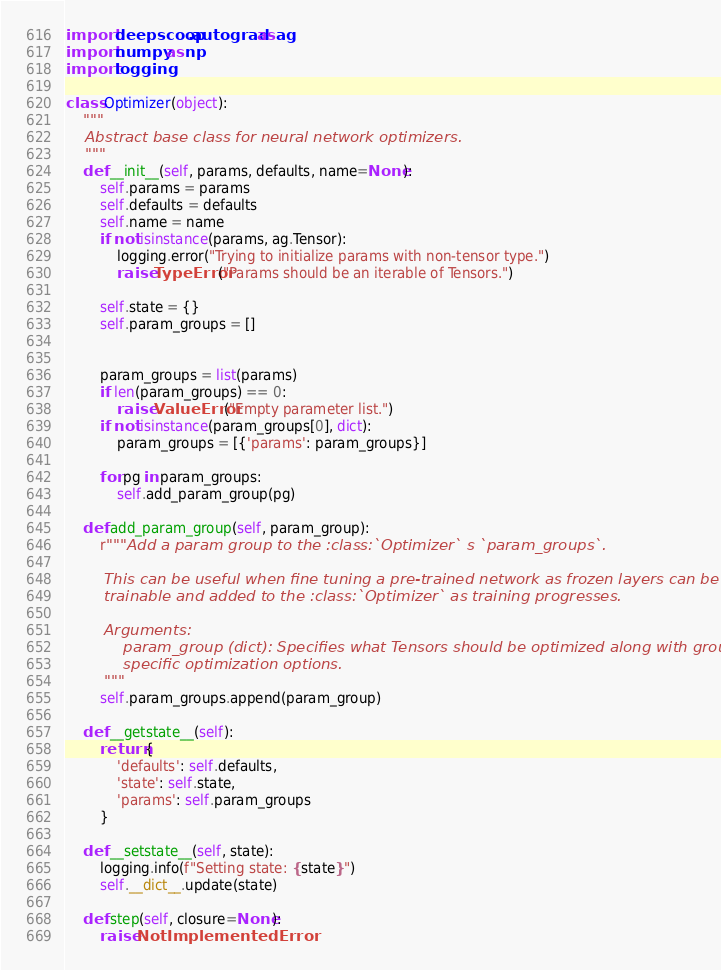<code> <loc_0><loc_0><loc_500><loc_500><_Python_>import deepscoop.autograd as ag
import numpy as np
import logging

class Optimizer(object):
	"""
	Abstract base class for neural network optimizers.
	"""
	def __init__(self, params, defaults, name=None):
		self.params = params
		self.defaults = defaults
		self.name = name
		if not isinstance(params, ag.Tensor):
			logging.error("Trying to initialize params with non-tensor type.")
			raise TypeError("Params should be an iterable of Tensors.")

		self.state = {}
		self.param_groups = []


		param_groups = list(params)
		if len(param_groups) == 0:
			raise ValueError("Empty parameter list.")
		if not isinstance(param_groups[0], dict):
			param_groups = [{'params': param_groups}]

		for pg in param_groups:
			self.add_param_group(pg)

	def add_param_group(self, param_group):
		r"""Add a param group to the :class:`Optimizer` s `param_groups`.

		This can be useful when fine tuning a pre-trained network as frozen layers can be made
		trainable and added to the :class:`Optimizer` as training progresses.

		Arguments:
			param_group (dict): Specifies what Tensors should be optimized along with group
			specific optimization options.
		"""
		self.param_groups.append(param_group)

	def __getstate__(self):
		return {
			'defaults': self.defaults,
			'state': self.state,
			'params': self.param_groups
		}

	def __setstate__(self, state):
		logging.info(f"Setting state: {state}")
		self.__dict__.update(state)

	def step(self, closure=None):
		raise NotImplementedError
</code> 